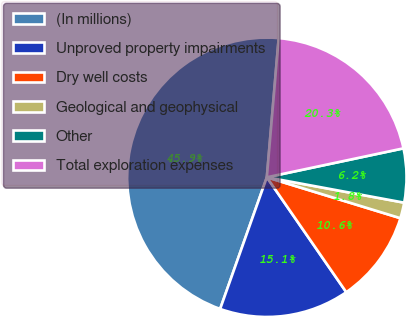Convert chart. <chart><loc_0><loc_0><loc_500><loc_500><pie_chart><fcel>(In millions)<fcel>Unproved property impairments<fcel>Dry well costs<fcel>Geological and geophysical<fcel>Other<fcel>Total exploration expenses<nl><fcel>45.92%<fcel>15.05%<fcel>10.64%<fcel>1.82%<fcel>6.23%<fcel>20.32%<nl></chart> 